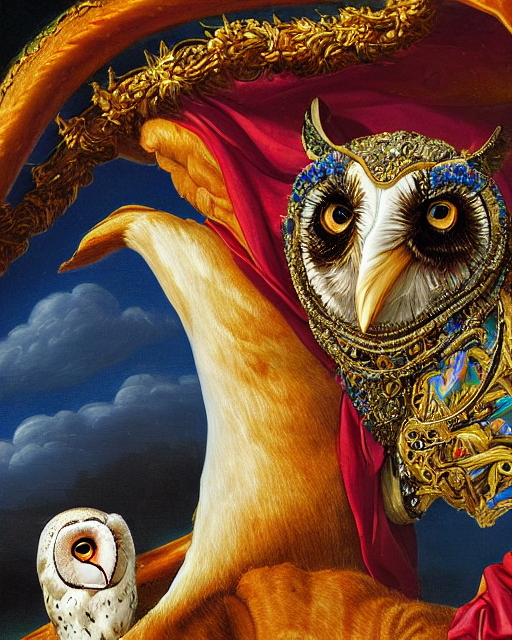Is there any apparent noise in the image?
A. Yes
B. No
Answer with the option's letter from the given choices directly.
 B. 